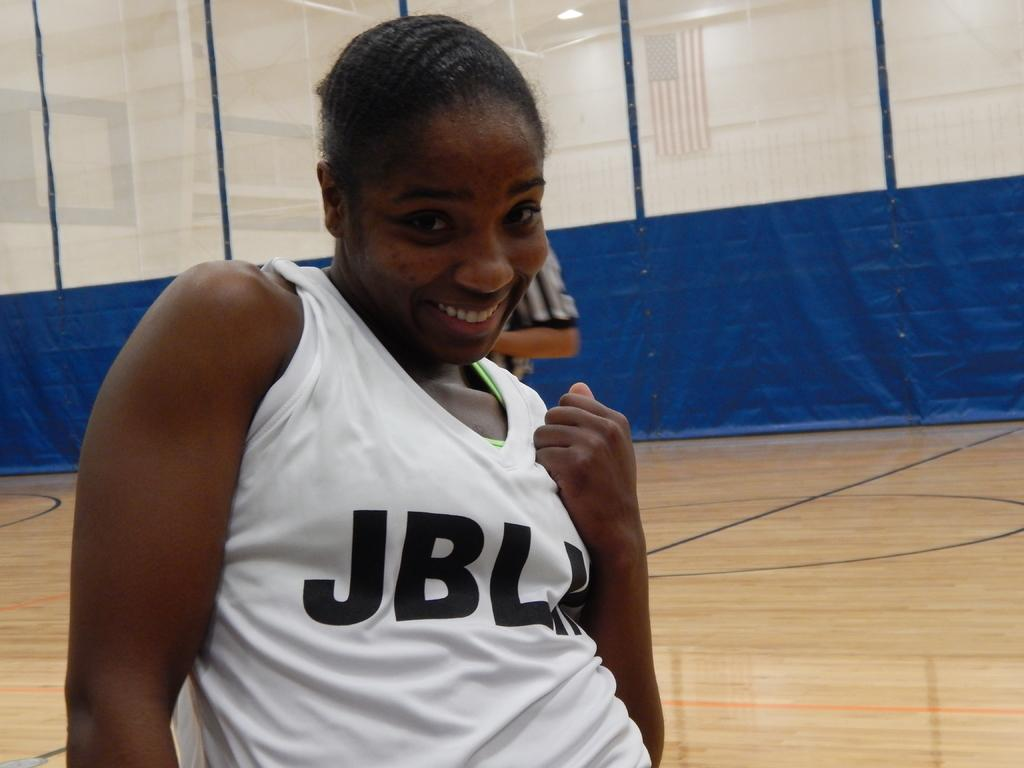Provide a one-sentence caption for the provided image. A girl stands on an indoor court, her shirt reads JBL and one other letter is hidden. 